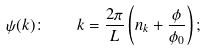<formula> <loc_0><loc_0><loc_500><loc_500>\psi ( k ) \colon \quad k = \frac { 2 \pi } { L } \left ( n _ { k } + \frac { \phi } { \phi _ { 0 } } \right ) ;</formula> 